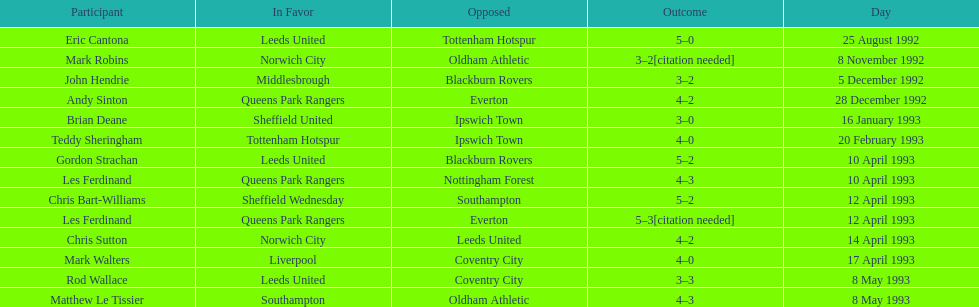What was the result of the match between queens park rangers and everton? 4-2. 